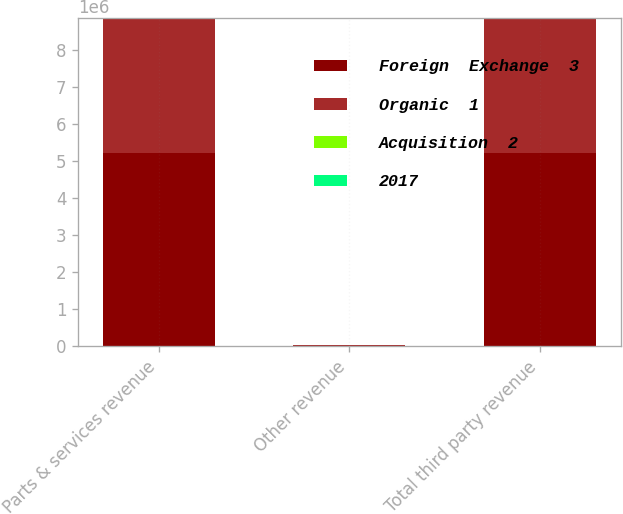<chart> <loc_0><loc_0><loc_500><loc_500><stacked_bar_chart><ecel><fcel>Parts & services revenue<fcel>Other revenue<fcel>Total third party revenue<nl><fcel>Foreign  Exchange  3<fcel>5.20223e+06<fcel>19523<fcel>5.22175e+06<nl><fcel>Organic  1<fcel>3.62891e+06<fcel>7905<fcel>3.63681e+06<nl><fcel>Acquisition  2<fcel>2.9<fcel>74.2<fcel>3.1<nl><fcel>2017<fcel>36.7<fcel>72.8<fcel>36.7<nl></chart> 